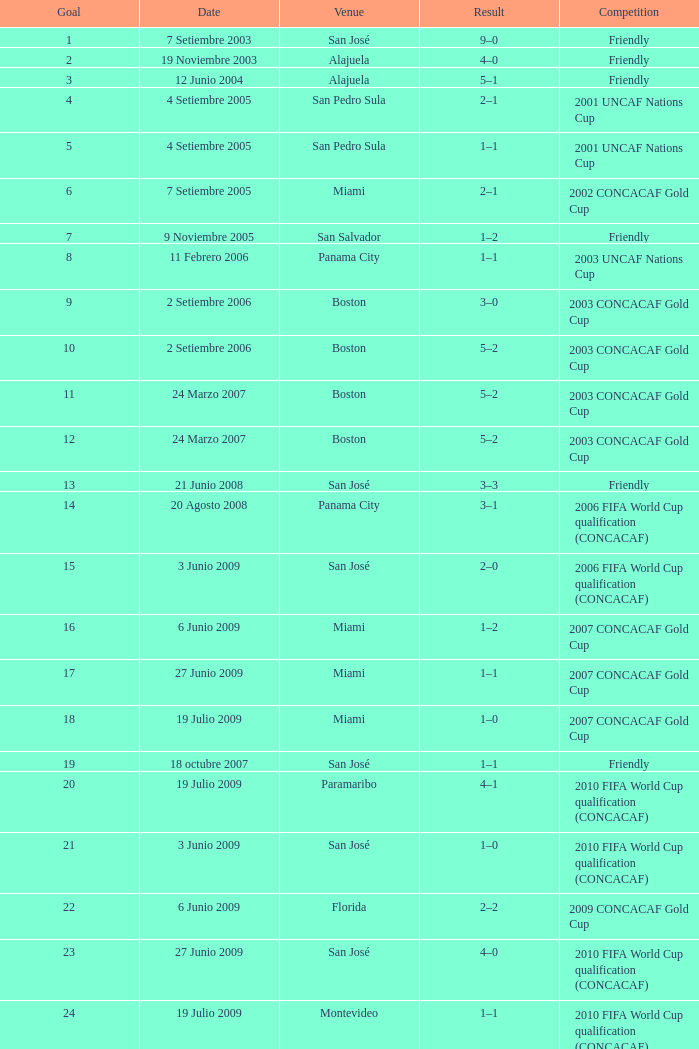How was the competition in which 6 goals were made? 2002 CONCACAF Gold Cup. 